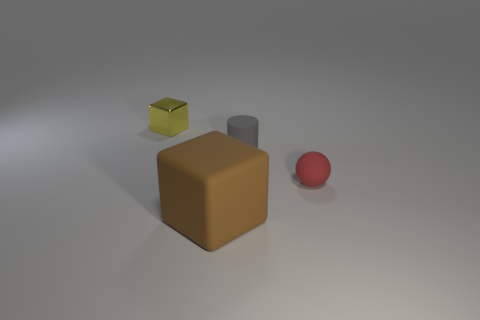What number of other things are the same material as the red object?
Your answer should be compact. 2. Is the material of the gray thing the same as the cube in front of the tiny yellow thing?
Give a very brief answer. Yes. Are there fewer small red rubber spheres to the left of the yellow shiny object than small matte objects to the left of the gray cylinder?
Provide a succinct answer. No. What is the color of the thing right of the small gray cylinder?
Keep it short and to the point. Red. What number of other things are there of the same color as the matte ball?
Offer a terse response. 0. There is a block that is to the right of the shiny thing; does it have the same size as the tiny cube?
Keep it short and to the point. No. What number of small matte balls are to the right of the tiny sphere?
Provide a succinct answer. 0. Are there any rubber things of the same size as the yellow metal thing?
Your answer should be very brief. Yes. Do the small metallic block and the small cylinder have the same color?
Keep it short and to the point. No. What is the color of the block that is right of the cube that is to the left of the big brown matte object?
Ensure brevity in your answer.  Brown. 